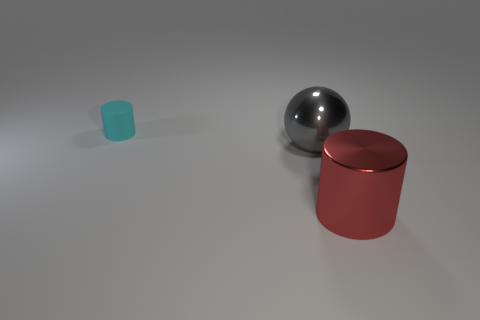Add 3 big yellow shiny cubes. How many objects exist? 6 Subtract all balls. How many objects are left? 2 Subtract all tiny rubber things. Subtract all metal objects. How many objects are left? 0 Add 3 cyan things. How many cyan things are left? 4 Add 2 small gray metallic balls. How many small gray metallic balls exist? 2 Subtract 0 purple spheres. How many objects are left? 3 